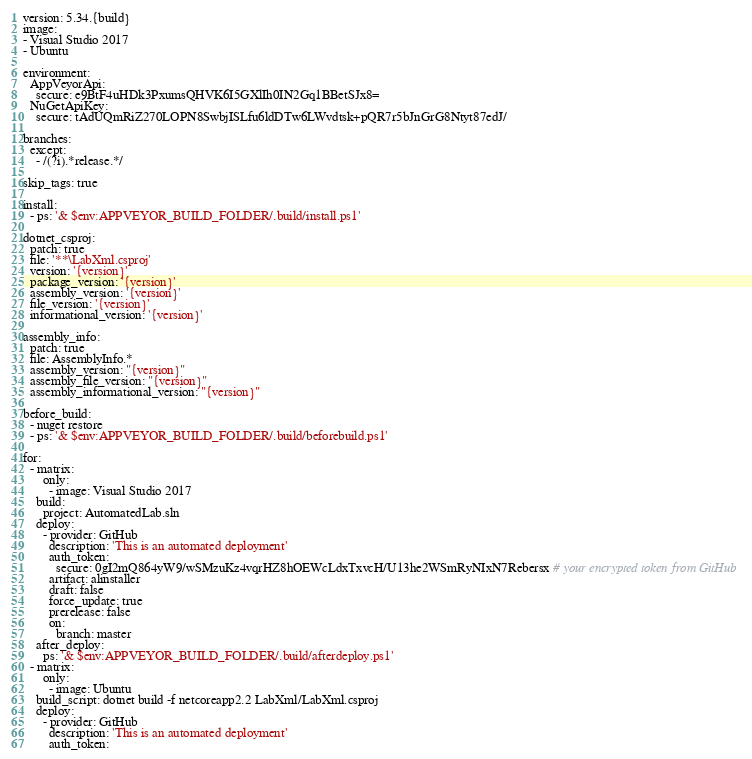<code> <loc_0><loc_0><loc_500><loc_500><_YAML_>version: 5.34.{build}
image:
- Visual Studio 2017
- Ubuntu

environment:
  AppVeyorApi:
    secure: e9BtF4uHDk3PxumsQHVK6I5GXlIh0IN2Gq1BBetSJx8=
  NuGetApiKey:
    secure: tAdUQmRiZ270LOPN8SwbjISLfu6ldDTw6LWvdtsk+pQR7r5bJnGrG8Ntyt87edJ/

branches:
  except:
    - /(?i).*release.*/

skip_tags: true

install:
  - ps: '& $env:APPVEYOR_BUILD_FOLDER/.build/install.ps1'

dotnet_csproj:
  patch: true
  file: '**\LabXml.csproj'
  version: '{version}'
  package_version: '{version}'
  assembly_version: '{version}'
  file_version: '{version}'
  informational_version: '{version}'

assembly_info:
  patch: true
  file: AssemblyInfo.*
  assembly_version: "{version}"
  assembly_file_version: "{version}"
  assembly_informational_version: "{version}"

before_build:
  - nuget restore
  - ps: '& $env:APPVEYOR_BUILD_FOLDER/.build/beforebuild.ps1'
        
for:
  - matrix:
      only:
        - image: Visual Studio 2017
    build:
      project: AutomatedLab.sln
    deploy:
      - provider: GitHub
        description: 'This is an automated deployment'
        auth_token:
          secure: 0gI2mQ864yW9/wSMzuKz4vqrHZ8hOEWcLdxTxvcH/U13he2WSmRyNIxN7Rebersx # your encrypted token from GitHub
        artifact: alinstaller
        draft: false
        force_update: true
        prerelease: false
        on:
          branch: master
    after_deploy:
      ps: '& $env:APPVEYOR_BUILD_FOLDER/.build/afterdeploy.ps1'
  - matrix:
      only:
        - image: Ubuntu
    build_script: dotnet build -f netcoreapp2.2 LabXml/LabXml.csproj
    deploy:
      - provider: GitHub
        description: 'This is an automated deployment'
        auth_token:</code> 